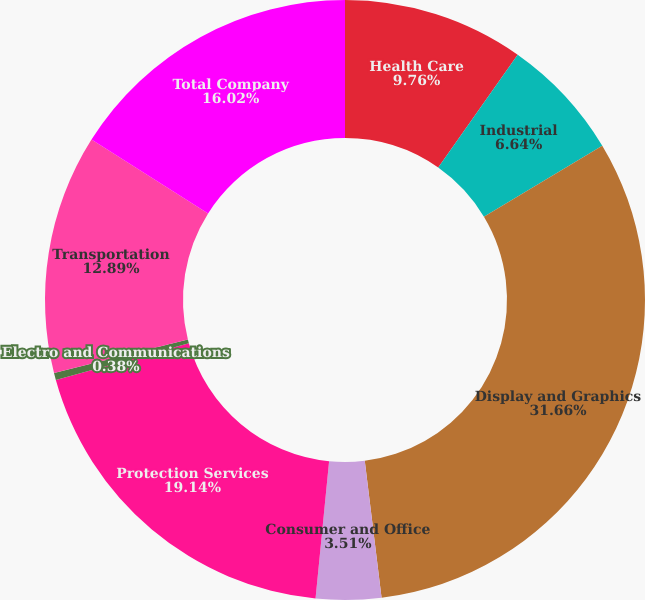Convert chart. <chart><loc_0><loc_0><loc_500><loc_500><pie_chart><fcel>Health Care<fcel>Industrial<fcel>Display and Graphics<fcel>Consumer and Office<fcel>Protection Services<fcel>Electro and Communications<fcel>Transportation<fcel>Total Company<nl><fcel>9.76%<fcel>6.64%<fcel>31.65%<fcel>3.51%<fcel>19.14%<fcel>0.38%<fcel>12.89%<fcel>16.02%<nl></chart> 